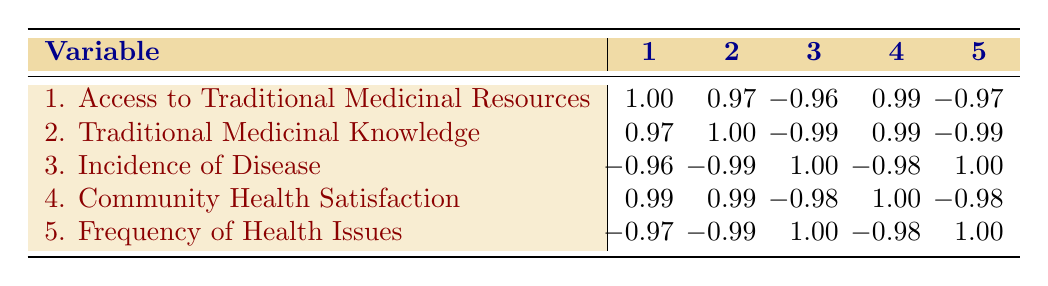What is the correlation between access to traditional medicinal resources and community health satisfaction? The table shows a correlation of 0.99 between access to traditional medicinal resources and community health satisfaction. This indicates a very strong positive relationship, meaning as access to traditional medicinal resources increases, so does community health satisfaction.
Answer: 0.99 Which community has the highest access to traditional medicinal resources? According to the table, the Ngardi community has the highest access to traditional medicinal resources with a value of 9.
Answer: Ngardi What is the correlation between incidence of disease and frequency of health issues? The table shows a correlation of 1.00 between incidence of disease and frequency of health issues. This indicates a perfect positive relationship; as the incidence of disease increases, the frequency of health issues also increases in exact proportion.
Answer: 1.00 Is it true that higher traditional medicinal knowledge correlates with lower incidence of disease? Yes, the correlation value between traditional medicinal knowledge and incidence of disease is -0.99. This indicates a strong negative relationship, suggesting that as traditional medicinal knowledge increases, the incidence of disease tends to decrease.
Answer: Yes What is the average value of access to traditional medicinal resources across all communities? To find the average, sum the access values (8 + 6 + 7 + 5 + 9 = 35) and divide by the number of communities (5). Thus, the average is 35/5 = 7.
Answer: 7 